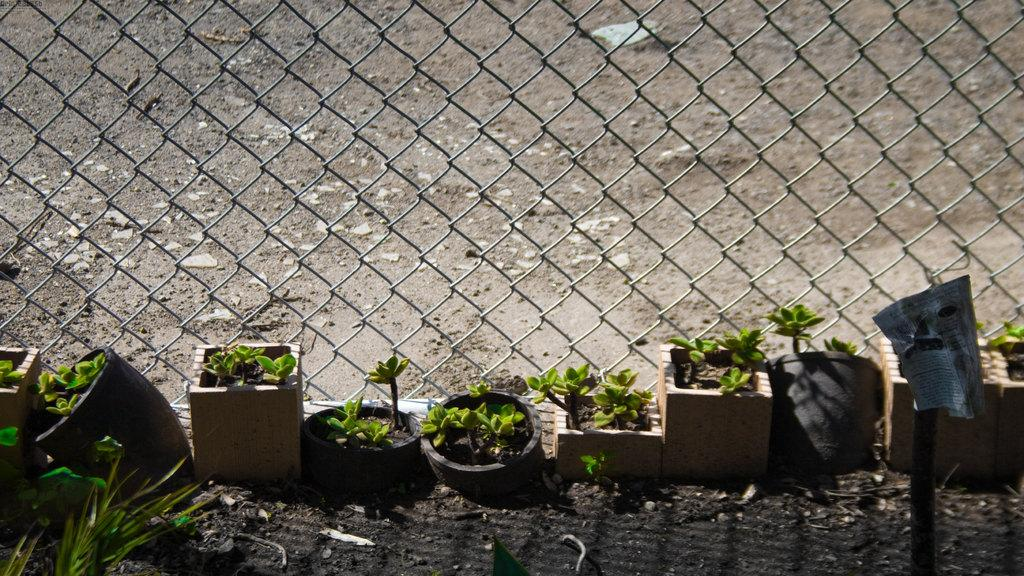What type of plants are in the image? There are plants in pots in the front of the image. What can be seen in the center of the image? There is a metal fence in the center of the image. How many slaves are visible in the image? There are no slaves present in the image. What color is the orange in the image? There is no orange present in the image. 